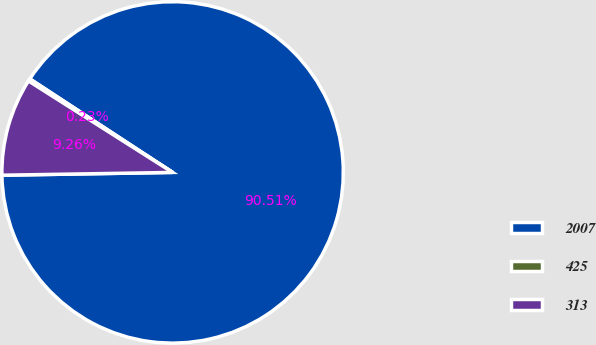<chart> <loc_0><loc_0><loc_500><loc_500><pie_chart><fcel>2007<fcel>425<fcel>313<nl><fcel>90.51%<fcel>0.23%<fcel>9.26%<nl></chart> 